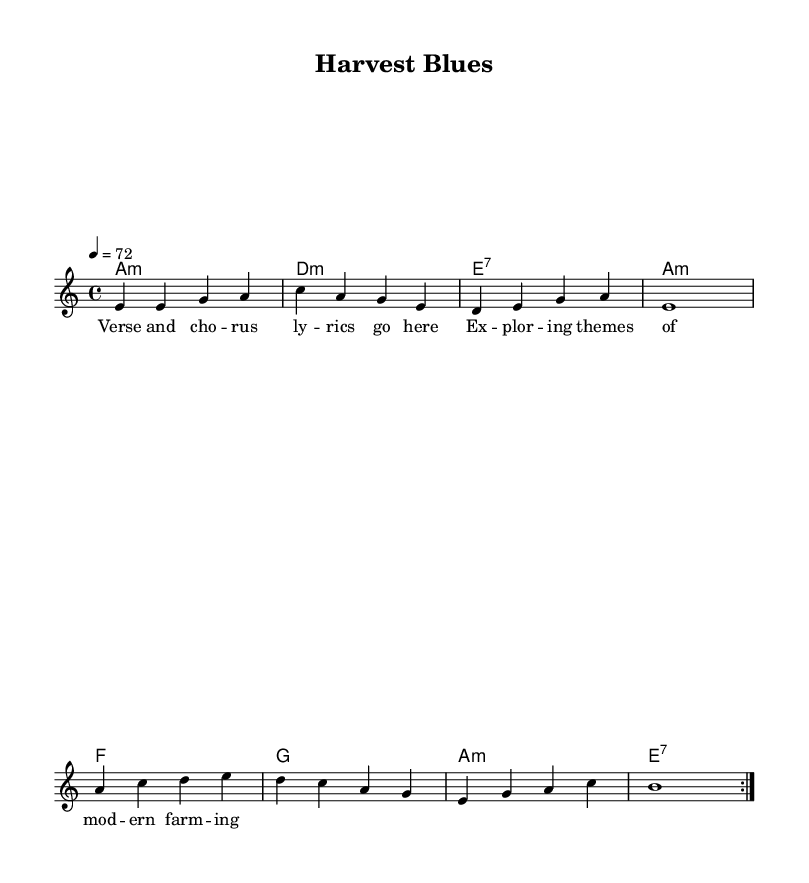What is the key signature of this music? The key signature is indicated at the beginning of the score, showing the presence of no sharps or flats, which means it is in A minor.
Answer: A minor What is the time signature of this piece? The time signature appears at the beginning of the score and indicates four beats per measure, specifically showing it as 4/4.
Answer: 4/4 What is the tempo marking for this piece? The tempo is noted right after the time signature, indicating that the piece should be played at a speed of 72 beats per minute.
Answer: 72 How many measures are repeated in the melody? The melody section shows a repeat sign, which indicates that the preceding measures will be played twice. In total, there are two measures being repeated.
Answer: 2 What type of song structure does this piece follow? The lyrics section is labeled as "Verse and chorus lyrics go here," implying a structure typical of blues songs that usually consist of verses and choruses, often repeating the same lyrical themes.
Answer: Verse and chorus What is the first chord of the harmony? The first chord is visually noted in the chord mode section of the score, which indicates the first chord to be played is an A minor chord.
Answer: A minor 